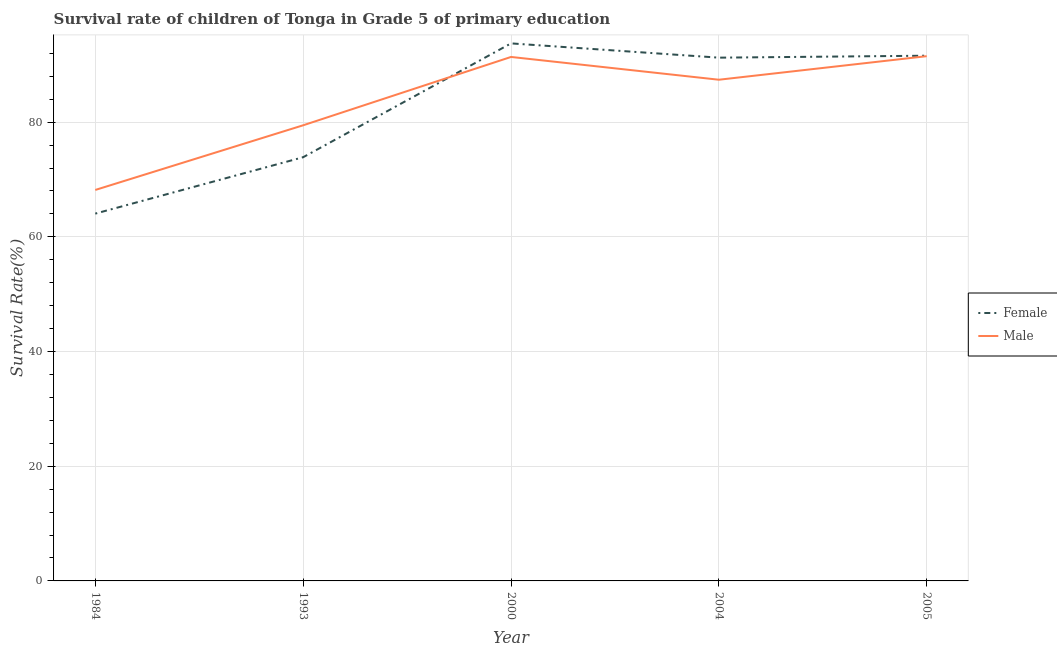How many different coloured lines are there?
Keep it short and to the point. 2. Is the number of lines equal to the number of legend labels?
Your answer should be compact. Yes. What is the survival rate of male students in primary education in 1993?
Your answer should be compact. 79.45. Across all years, what is the maximum survival rate of female students in primary education?
Make the answer very short. 93.73. Across all years, what is the minimum survival rate of male students in primary education?
Your answer should be compact. 68.17. In which year was the survival rate of female students in primary education minimum?
Your response must be concise. 1984. What is the total survival rate of female students in primary education in the graph?
Offer a very short reply. 414.48. What is the difference between the survival rate of female students in primary education in 1984 and that in 2004?
Ensure brevity in your answer.  -27.19. What is the difference between the survival rate of female students in primary education in 2004 and the survival rate of male students in primary education in 1993?
Your answer should be compact. 11.79. What is the average survival rate of male students in primary education per year?
Provide a succinct answer. 83.58. In the year 1984, what is the difference between the survival rate of male students in primary education and survival rate of female students in primary education?
Keep it short and to the point. 4.12. What is the ratio of the survival rate of female students in primary education in 2000 to that in 2004?
Give a very brief answer. 1.03. Is the survival rate of male students in primary education in 1984 less than that in 2005?
Ensure brevity in your answer.  Yes. Is the difference between the survival rate of female students in primary education in 1984 and 2000 greater than the difference between the survival rate of male students in primary education in 1984 and 2000?
Your answer should be compact. No. What is the difference between the highest and the second highest survival rate of male students in primary education?
Provide a short and direct response. 0.13. What is the difference between the highest and the lowest survival rate of female students in primary education?
Ensure brevity in your answer.  29.68. How many lines are there?
Offer a terse response. 2. What is the difference between two consecutive major ticks on the Y-axis?
Make the answer very short. 20. Are the values on the major ticks of Y-axis written in scientific E-notation?
Keep it short and to the point. No. Does the graph contain any zero values?
Offer a terse response. No. Does the graph contain grids?
Keep it short and to the point. Yes. Where does the legend appear in the graph?
Ensure brevity in your answer.  Center right. How are the legend labels stacked?
Provide a succinct answer. Vertical. What is the title of the graph?
Make the answer very short. Survival rate of children of Tonga in Grade 5 of primary education. Does "Under-five" appear as one of the legend labels in the graph?
Provide a short and direct response. No. What is the label or title of the X-axis?
Give a very brief answer. Year. What is the label or title of the Y-axis?
Offer a very short reply. Survival Rate(%). What is the Survival Rate(%) in Female in 1984?
Your answer should be compact. 64.05. What is the Survival Rate(%) in Male in 1984?
Make the answer very short. 68.17. What is the Survival Rate(%) in Female in 1993?
Your response must be concise. 73.88. What is the Survival Rate(%) in Male in 1993?
Ensure brevity in your answer.  79.45. What is the Survival Rate(%) of Female in 2000?
Your answer should be compact. 93.73. What is the Survival Rate(%) in Male in 2000?
Make the answer very short. 91.36. What is the Survival Rate(%) in Female in 2004?
Your answer should be compact. 91.24. What is the Survival Rate(%) of Male in 2004?
Your response must be concise. 87.39. What is the Survival Rate(%) of Female in 2005?
Keep it short and to the point. 91.58. What is the Survival Rate(%) in Male in 2005?
Your answer should be compact. 91.5. Across all years, what is the maximum Survival Rate(%) in Female?
Your answer should be compact. 93.73. Across all years, what is the maximum Survival Rate(%) in Male?
Offer a terse response. 91.5. Across all years, what is the minimum Survival Rate(%) in Female?
Your answer should be compact. 64.05. Across all years, what is the minimum Survival Rate(%) in Male?
Offer a terse response. 68.17. What is the total Survival Rate(%) in Female in the graph?
Offer a terse response. 414.48. What is the total Survival Rate(%) of Male in the graph?
Provide a short and direct response. 417.88. What is the difference between the Survival Rate(%) in Female in 1984 and that in 1993?
Your answer should be compact. -9.83. What is the difference between the Survival Rate(%) in Male in 1984 and that in 1993?
Your answer should be compact. -11.28. What is the difference between the Survival Rate(%) in Female in 1984 and that in 2000?
Make the answer very short. -29.68. What is the difference between the Survival Rate(%) of Male in 1984 and that in 2000?
Ensure brevity in your answer.  -23.19. What is the difference between the Survival Rate(%) in Female in 1984 and that in 2004?
Your answer should be compact. -27.19. What is the difference between the Survival Rate(%) in Male in 1984 and that in 2004?
Your response must be concise. -19.22. What is the difference between the Survival Rate(%) of Female in 1984 and that in 2005?
Give a very brief answer. -27.54. What is the difference between the Survival Rate(%) in Male in 1984 and that in 2005?
Your answer should be compact. -23.33. What is the difference between the Survival Rate(%) of Female in 1993 and that in 2000?
Keep it short and to the point. -19.85. What is the difference between the Survival Rate(%) of Male in 1993 and that in 2000?
Make the answer very short. -11.92. What is the difference between the Survival Rate(%) of Female in 1993 and that in 2004?
Your response must be concise. -17.36. What is the difference between the Survival Rate(%) in Male in 1993 and that in 2004?
Offer a very short reply. -7.95. What is the difference between the Survival Rate(%) of Female in 1993 and that in 2005?
Your response must be concise. -17.7. What is the difference between the Survival Rate(%) of Male in 1993 and that in 2005?
Your answer should be very brief. -12.05. What is the difference between the Survival Rate(%) of Female in 2000 and that in 2004?
Your answer should be very brief. 2.49. What is the difference between the Survival Rate(%) in Male in 2000 and that in 2004?
Provide a succinct answer. 3.97. What is the difference between the Survival Rate(%) in Female in 2000 and that in 2005?
Provide a short and direct response. 2.15. What is the difference between the Survival Rate(%) in Male in 2000 and that in 2005?
Give a very brief answer. -0.13. What is the difference between the Survival Rate(%) in Female in 2004 and that in 2005?
Your response must be concise. -0.34. What is the difference between the Survival Rate(%) in Male in 2004 and that in 2005?
Offer a terse response. -4.1. What is the difference between the Survival Rate(%) in Female in 1984 and the Survival Rate(%) in Male in 1993?
Your response must be concise. -15.4. What is the difference between the Survival Rate(%) of Female in 1984 and the Survival Rate(%) of Male in 2000?
Provide a short and direct response. -27.32. What is the difference between the Survival Rate(%) in Female in 1984 and the Survival Rate(%) in Male in 2004?
Offer a terse response. -23.35. What is the difference between the Survival Rate(%) of Female in 1984 and the Survival Rate(%) of Male in 2005?
Your answer should be very brief. -27.45. What is the difference between the Survival Rate(%) of Female in 1993 and the Survival Rate(%) of Male in 2000?
Offer a terse response. -17.48. What is the difference between the Survival Rate(%) in Female in 1993 and the Survival Rate(%) in Male in 2004?
Keep it short and to the point. -13.51. What is the difference between the Survival Rate(%) in Female in 1993 and the Survival Rate(%) in Male in 2005?
Your answer should be compact. -17.62. What is the difference between the Survival Rate(%) in Female in 2000 and the Survival Rate(%) in Male in 2004?
Make the answer very short. 6.34. What is the difference between the Survival Rate(%) of Female in 2000 and the Survival Rate(%) of Male in 2005?
Your response must be concise. 2.23. What is the difference between the Survival Rate(%) in Female in 2004 and the Survival Rate(%) in Male in 2005?
Offer a very short reply. -0.26. What is the average Survival Rate(%) in Female per year?
Your answer should be compact. 82.9. What is the average Survival Rate(%) of Male per year?
Your answer should be very brief. 83.58. In the year 1984, what is the difference between the Survival Rate(%) in Female and Survival Rate(%) in Male?
Your answer should be very brief. -4.12. In the year 1993, what is the difference between the Survival Rate(%) in Female and Survival Rate(%) in Male?
Your answer should be very brief. -5.57. In the year 2000, what is the difference between the Survival Rate(%) of Female and Survival Rate(%) of Male?
Your answer should be very brief. 2.37. In the year 2004, what is the difference between the Survival Rate(%) in Female and Survival Rate(%) in Male?
Offer a terse response. 3.85. In the year 2005, what is the difference between the Survival Rate(%) of Female and Survival Rate(%) of Male?
Your answer should be compact. 0.08. What is the ratio of the Survival Rate(%) in Female in 1984 to that in 1993?
Offer a very short reply. 0.87. What is the ratio of the Survival Rate(%) in Male in 1984 to that in 1993?
Offer a terse response. 0.86. What is the ratio of the Survival Rate(%) of Female in 1984 to that in 2000?
Offer a very short reply. 0.68. What is the ratio of the Survival Rate(%) in Male in 1984 to that in 2000?
Your answer should be compact. 0.75. What is the ratio of the Survival Rate(%) in Female in 1984 to that in 2004?
Keep it short and to the point. 0.7. What is the ratio of the Survival Rate(%) in Male in 1984 to that in 2004?
Keep it short and to the point. 0.78. What is the ratio of the Survival Rate(%) in Female in 1984 to that in 2005?
Your answer should be very brief. 0.7. What is the ratio of the Survival Rate(%) of Male in 1984 to that in 2005?
Provide a short and direct response. 0.75. What is the ratio of the Survival Rate(%) in Female in 1993 to that in 2000?
Your answer should be compact. 0.79. What is the ratio of the Survival Rate(%) of Male in 1993 to that in 2000?
Provide a short and direct response. 0.87. What is the ratio of the Survival Rate(%) in Female in 1993 to that in 2004?
Your answer should be compact. 0.81. What is the ratio of the Survival Rate(%) of Female in 1993 to that in 2005?
Your answer should be very brief. 0.81. What is the ratio of the Survival Rate(%) of Male in 1993 to that in 2005?
Provide a succinct answer. 0.87. What is the ratio of the Survival Rate(%) in Female in 2000 to that in 2004?
Make the answer very short. 1.03. What is the ratio of the Survival Rate(%) of Male in 2000 to that in 2004?
Keep it short and to the point. 1.05. What is the ratio of the Survival Rate(%) in Female in 2000 to that in 2005?
Make the answer very short. 1.02. What is the ratio of the Survival Rate(%) in Male in 2000 to that in 2005?
Make the answer very short. 1. What is the ratio of the Survival Rate(%) of Female in 2004 to that in 2005?
Give a very brief answer. 1. What is the ratio of the Survival Rate(%) of Male in 2004 to that in 2005?
Provide a short and direct response. 0.96. What is the difference between the highest and the second highest Survival Rate(%) in Female?
Provide a short and direct response. 2.15. What is the difference between the highest and the second highest Survival Rate(%) of Male?
Make the answer very short. 0.13. What is the difference between the highest and the lowest Survival Rate(%) in Female?
Offer a very short reply. 29.68. What is the difference between the highest and the lowest Survival Rate(%) in Male?
Ensure brevity in your answer.  23.33. 